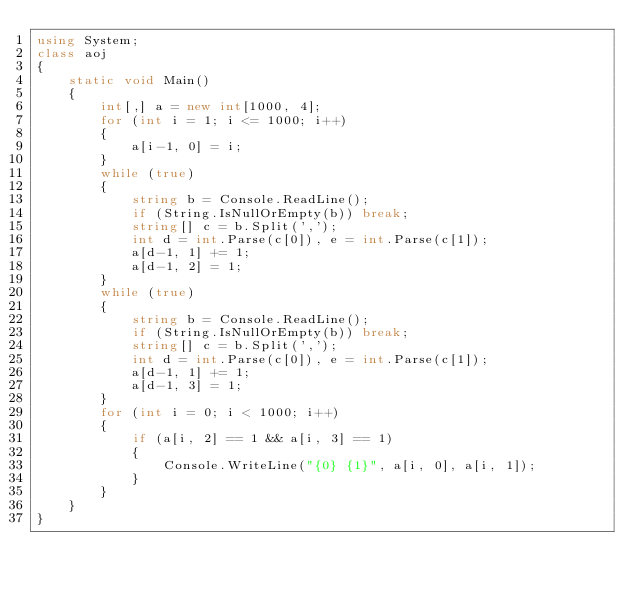<code> <loc_0><loc_0><loc_500><loc_500><_C#_>using System;
class aoj
{
    static void Main()
    {
        int[,] a = new int[1000, 4];
        for (int i = 1; i <= 1000; i++)
        {
            a[i-1, 0] = i;
        }
        while (true)
        {
            string b = Console.ReadLine();
            if (String.IsNullOrEmpty(b)) break;
            string[] c = b.Split(',');
            int d = int.Parse(c[0]), e = int.Parse(c[1]);
            a[d-1, 1] += 1;
            a[d-1, 2] = 1;
        }
        while (true)
        {
            string b = Console.ReadLine();
            if (String.IsNullOrEmpty(b)) break;
            string[] c = b.Split(',');
            int d = int.Parse(c[0]), e = int.Parse(c[1]);
            a[d-1, 1] += 1;
            a[d-1, 3] = 1;
        }
        for (int i = 0; i < 1000; i++)
        {
            if (a[i, 2] == 1 && a[i, 3] == 1)
            {
                Console.WriteLine("{0} {1}", a[i, 0], a[i, 1]);
            }
        }
    }
}</code> 